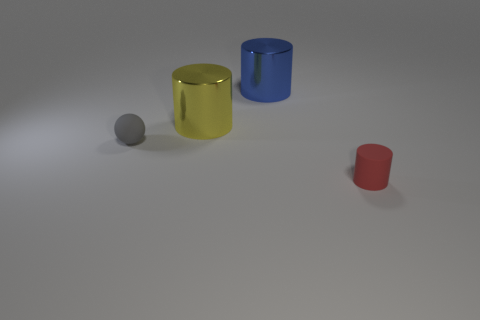What is the color of the tiny ball? The small ball displayed in the image appears to exhibit a shade of gray, reflecting a minimalist and neutral tone amidst the more vivid colors of the surrounding objects. 